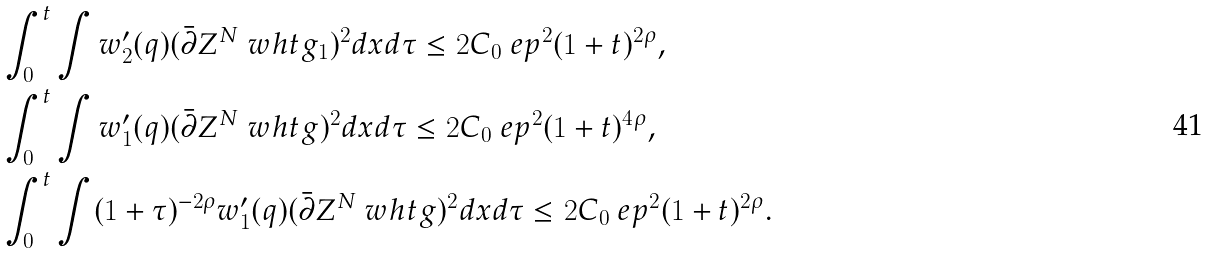<formula> <loc_0><loc_0><loc_500><loc_500>& \int _ { 0 } ^ { t } \int w _ { 2 } ^ { \prime } ( q ) ( \bar { \partial } Z ^ { N } \ w h t g _ { 1 } ) ^ { 2 } d x d \tau \leq 2 C _ { 0 } \ e p ^ { 2 } ( 1 + t ) ^ { 2 \rho } , \\ & \int _ { 0 } ^ { t } \int w _ { 1 } ^ { \prime } ( q ) ( \bar { \partial } Z ^ { N } \ w h t g ) ^ { 2 } d x d \tau \leq 2 C _ { 0 } \ e p ^ { 2 } ( 1 + t ) ^ { 4 \rho } , \\ & \int _ { 0 } ^ { t } \int ( 1 + \tau ) ^ { - 2 \rho } w _ { 1 } ^ { \prime } ( q ) ( \bar { \partial } Z ^ { N } \ w h t g ) ^ { 2 } d x d \tau \leq 2 C _ { 0 } \ e p ^ { 2 } ( 1 + t ) ^ { 2 \rho } .</formula> 